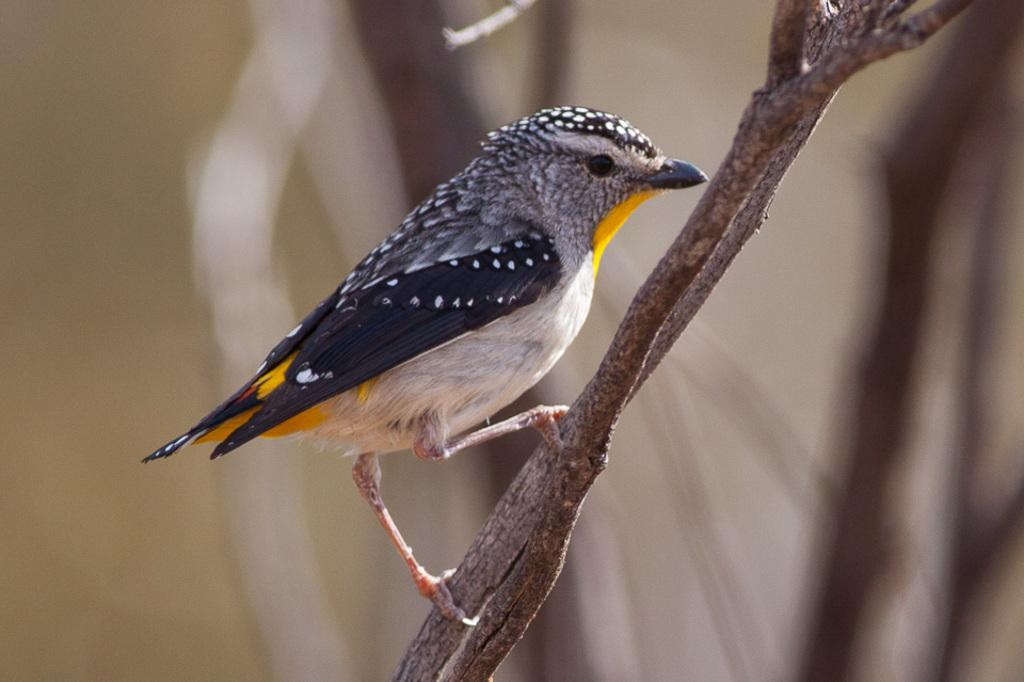What type of animal can be seen in the image? There is a bird in the image. Where is the bird located in the image? The bird is standing on a tree branch. Can you describe the background of the image? The background of the image is blurry. What type of lipstick is the bird wearing in the image? There is no lipstick or any indication of makeup on the bird in the image. Is there a chain visible in the image? No, there is no chain present in the image. 